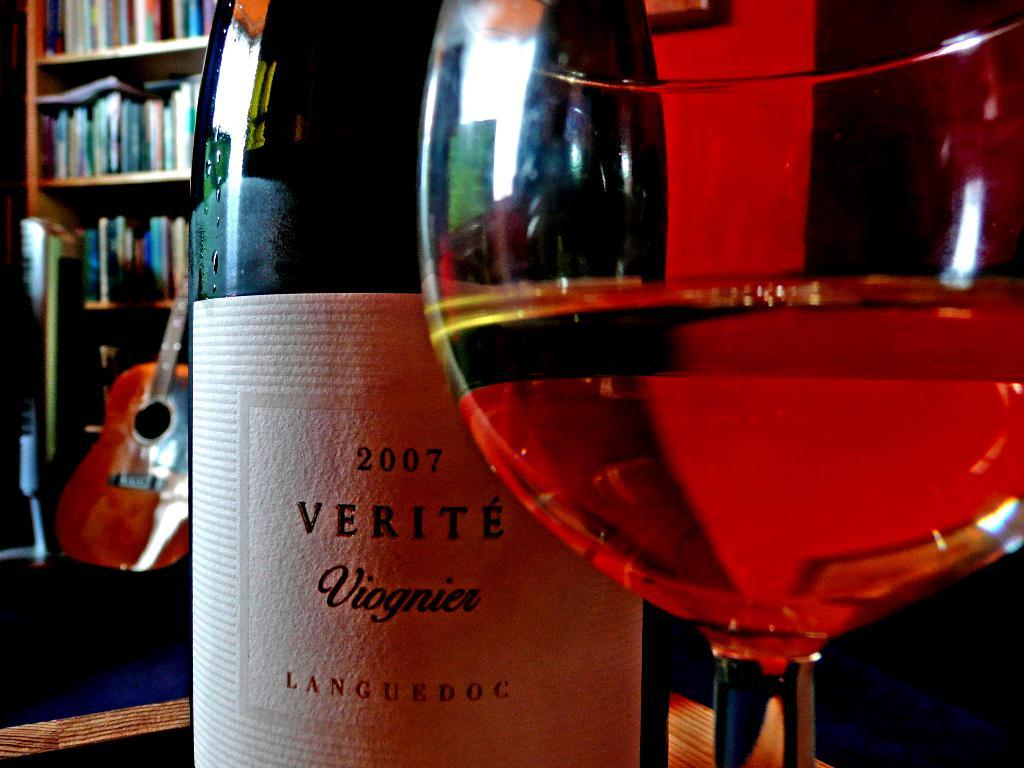<image>
Give a short and clear explanation of the subsequent image. A Glass of wine is positioned in front of a Verite bottle from 2007. 